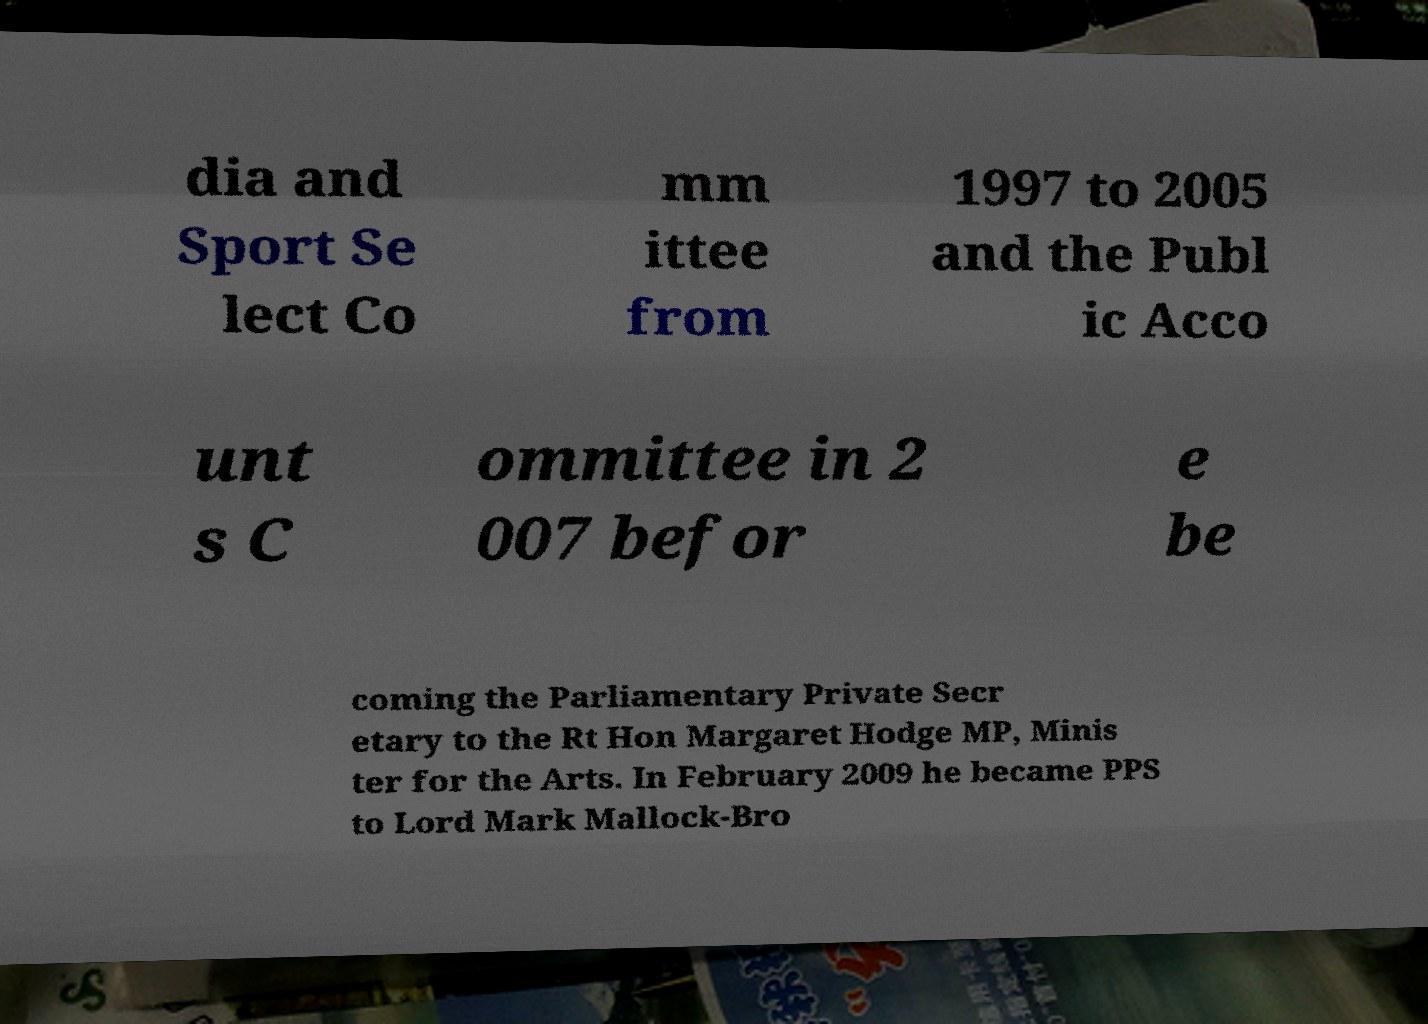There's text embedded in this image that I need extracted. Can you transcribe it verbatim? dia and Sport Se lect Co mm ittee from 1997 to 2005 and the Publ ic Acco unt s C ommittee in 2 007 befor e be coming the Parliamentary Private Secr etary to the Rt Hon Margaret Hodge MP, Minis ter for the Arts. In February 2009 he became PPS to Lord Mark Mallock-Bro 